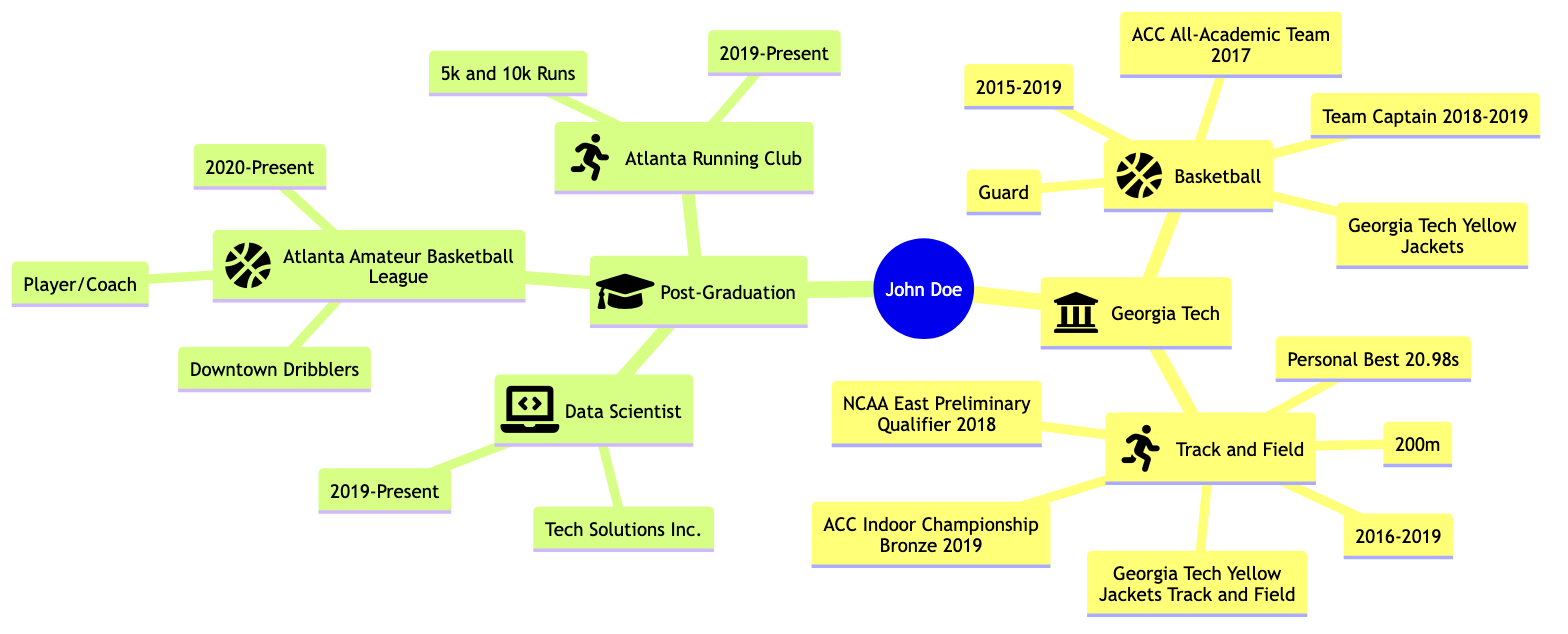What university did John Doe attend? The diagram clearly identifies "Georgia Tech" as the university associated with John Doe, appearing directly under his name in the family tree structure.
Answer: Georgia Tech What sport did John Doe play as a guard? The diagram lists "Basketball" under John Doe's athletic career, specifically mentioning his position as "Guard," which indicates the position he played in that sport.
Answer: Basketball How many sports teams did John Doe participate in during his time at Georgia Tech? By examining the diagram, we see that John Doe participated in two sports: Basketball and Track and Field. Therefore, the count of sports teams he was a member of is two.
Answer: 2 What was John Doe's personal best in track and field? The diagram shows that John Doe achieved a "Personal Best" of "20.98s" in the 200m event while participating in track and field.
Answer: 20.98s Which league did John Doe join after graduation? According to the diagram, after graduation, John Doe became involved in the "Atlanta Amateur Basketball League," which is listed as one of his continued athletic involvements.
Answer: Atlanta Amateur Basketball League What role does John Doe hold in the Downtown Dribblers? The diagram specifies that John Doe participates as a "Player/Coach" for the "Downtown Dribblers" in the Atlanta Amateur Basketball League, indicating his dual role on the team.
Answer: Player/Coach How many years did John Doe actively play basketball at Georgia Tech? The diagram explicitly states that John Doe was active on the basketball team from 2015 to 2019, which is a total of 4 years (inclusive).
Answer: 4 years What accolade did John Doe achieve in basketball during the 2017 season? The diagram mentions that John Doe was part of the "ACC All-Academic Team 2017," indicating a specific accolade he received while playing basketball in that season.
Answer: ACC All-Academic Team 2017 What position did John Doe compete in track and field? The diagram indicates that John Doe competed in the "200m" event while being a member of the "Georgia Tech Yellow Jackets Track and Field" team, specifying his event rather than a position like in basketball.
Answer: 200m 